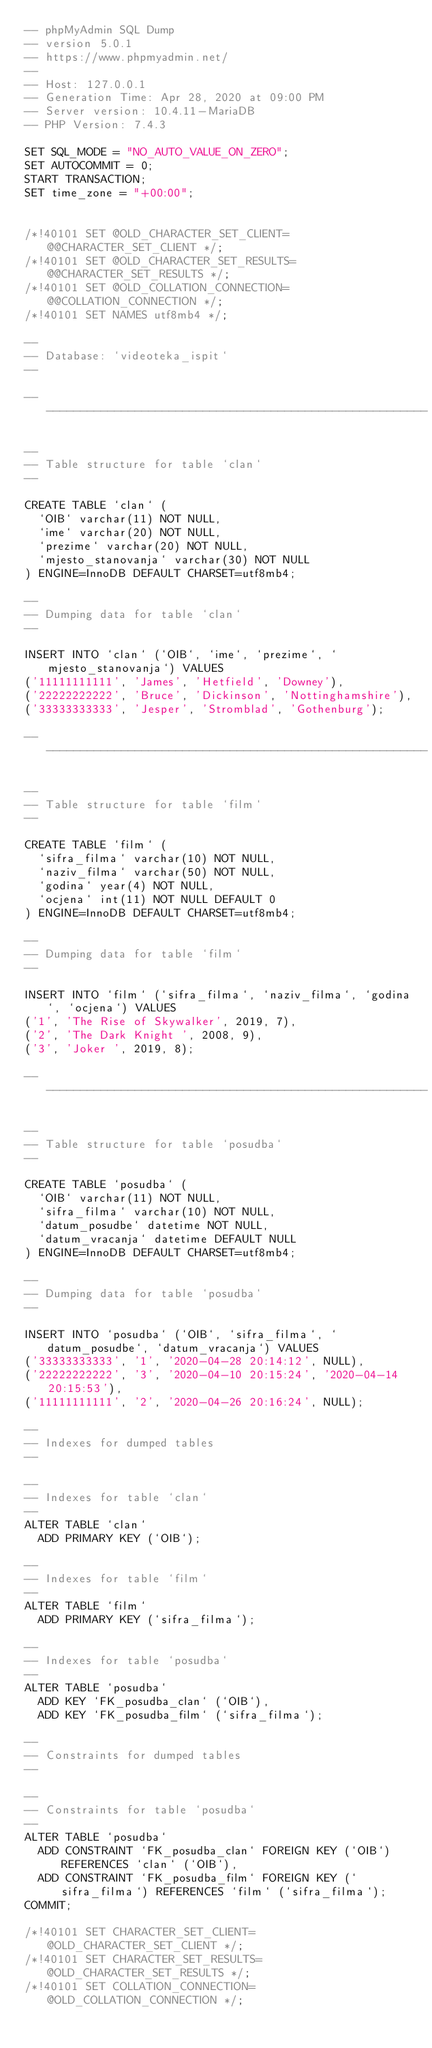<code> <loc_0><loc_0><loc_500><loc_500><_SQL_>-- phpMyAdmin SQL Dump
-- version 5.0.1
-- https://www.phpmyadmin.net/
--
-- Host: 127.0.0.1
-- Generation Time: Apr 28, 2020 at 09:00 PM
-- Server version: 10.4.11-MariaDB
-- PHP Version: 7.4.3

SET SQL_MODE = "NO_AUTO_VALUE_ON_ZERO";
SET AUTOCOMMIT = 0;
START TRANSACTION;
SET time_zone = "+00:00";


/*!40101 SET @OLD_CHARACTER_SET_CLIENT=@@CHARACTER_SET_CLIENT */;
/*!40101 SET @OLD_CHARACTER_SET_RESULTS=@@CHARACTER_SET_RESULTS */;
/*!40101 SET @OLD_COLLATION_CONNECTION=@@COLLATION_CONNECTION */;
/*!40101 SET NAMES utf8mb4 */;

--
-- Database: `videoteka_ispit`
--

-- --------------------------------------------------------

--
-- Table structure for table `clan`
--

CREATE TABLE `clan` (
  `OIB` varchar(11) NOT NULL,
  `ime` varchar(20) NOT NULL,
  `prezime` varchar(20) NOT NULL,
  `mjesto_stanovanja` varchar(30) NOT NULL
) ENGINE=InnoDB DEFAULT CHARSET=utf8mb4;

--
-- Dumping data for table `clan`
--

INSERT INTO `clan` (`OIB`, `ime`, `prezime`, `mjesto_stanovanja`) VALUES
('11111111111', 'James', 'Hetfield', 'Downey'),
('22222222222', 'Bruce', 'Dickinson', 'Nottinghamshire'),
('33333333333', 'Jesper', 'Stromblad', 'Gothenburg');

-- --------------------------------------------------------

--
-- Table structure for table `film`
--

CREATE TABLE `film` (
  `sifra_filma` varchar(10) NOT NULL,
  `naziv_filma` varchar(50) NOT NULL,
  `godina` year(4) NOT NULL,
  `ocjena` int(11) NOT NULL DEFAULT 0
) ENGINE=InnoDB DEFAULT CHARSET=utf8mb4;

--
-- Dumping data for table `film`
--

INSERT INTO `film` (`sifra_filma`, `naziv_filma`, `godina`, `ocjena`) VALUES
('1', 'The Rise of Skywalker', 2019, 7),
('2', 'The Dark Knight ', 2008, 9),
('3', 'Joker ', 2019, 8);

-- --------------------------------------------------------

--
-- Table structure for table `posudba`
--

CREATE TABLE `posudba` (
  `OIB` varchar(11) NOT NULL,
  `sifra_filma` varchar(10) NOT NULL,
  `datum_posudbe` datetime NOT NULL,
  `datum_vracanja` datetime DEFAULT NULL
) ENGINE=InnoDB DEFAULT CHARSET=utf8mb4;

--
-- Dumping data for table `posudba`
--

INSERT INTO `posudba` (`OIB`, `sifra_filma`, `datum_posudbe`, `datum_vracanja`) VALUES
('33333333333', '1', '2020-04-28 20:14:12', NULL),
('22222222222', '3', '2020-04-10 20:15:24', '2020-04-14 20:15:53'),
('11111111111', '2', '2020-04-26 20:16:24', NULL);

--
-- Indexes for dumped tables
--

--
-- Indexes for table `clan`
--
ALTER TABLE `clan`
  ADD PRIMARY KEY (`OIB`);

--
-- Indexes for table `film`
--
ALTER TABLE `film`
  ADD PRIMARY KEY (`sifra_filma`);

--
-- Indexes for table `posudba`
--
ALTER TABLE `posudba`
  ADD KEY `FK_posudba_clan` (`OIB`),
  ADD KEY `FK_posudba_film` (`sifra_filma`);

--
-- Constraints for dumped tables
--

--
-- Constraints for table `posudba`
--
ALTER TABLE `posudba`
  ADD CONSTRAINT `FK_posudba_clan` FOREIGN KEY (`OIB`) REFERENCES `clan` (`OIB`),
  ADD CONSTRAINT `FK_posudba_film` FOREIGN KEY (`sifra_filma`) REFERENCES `film` (`sifra_filma`);
COMMIT;

/*!40101 SET CHARACTER_SET_CLIENT=@OLD_CHARACTER_SET_CLIENT */;
/*!40101 SET CHARACTER_SET_RESULTS=@OLD_CHARACTER_SET_RESULTS */;
/*!40101 SET COLLATION_CONNECTION=@OLD_COLLATION_CONNECTION */;
</code> 